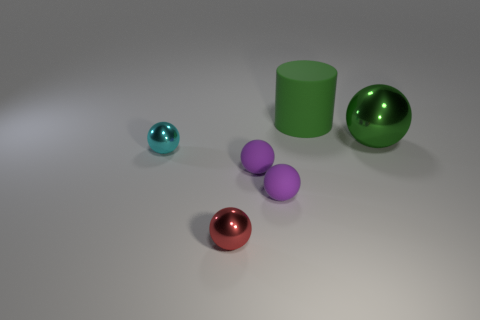Subtract 1 spheres. How many spheres are left? 4 Add 1 purple objects. How many objects exist? 7 Subtract all cylinders. How many objects are left? 5 Add 2 small purple cubes. How many small purple cubes exist? 2 Subtract 0 brown cubes. How many objects are left? 6 Subtract all purple rubber things. Subtract all small red shiny things. How many objects are left? 3 Add 3 cyan metallic objects. How many cyan metallic objects are left? 4 